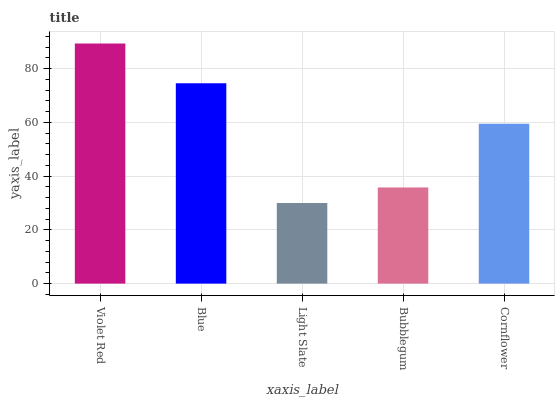Is Light Slate the minimum?
Answer yes or no. Yes. Is Violet Red the maximum?
Answer yes or no. Yes. Is Blue the minimum?
Answer yes or no. No. Is Blue the maximum?
Answer yes or no. No. Is Violet Red greater than Blue?
Answer yes or no. Yes. Is Blue less than Violet Red?
Answer yes or no. Yes. Is Blue greater than Violet Red?
Answer yes or no. No. Is Violet Red less than Blue?
Answer yes or no. No. Is Cornflower the high median?
Answer yes or no. Yes. Is Cornflower the low median?
Answer yes or no. Yes. Is Light Slate the high median?
Answer yes or no. No. Is Bubblegum the low median?
Answer yes or no. No. 